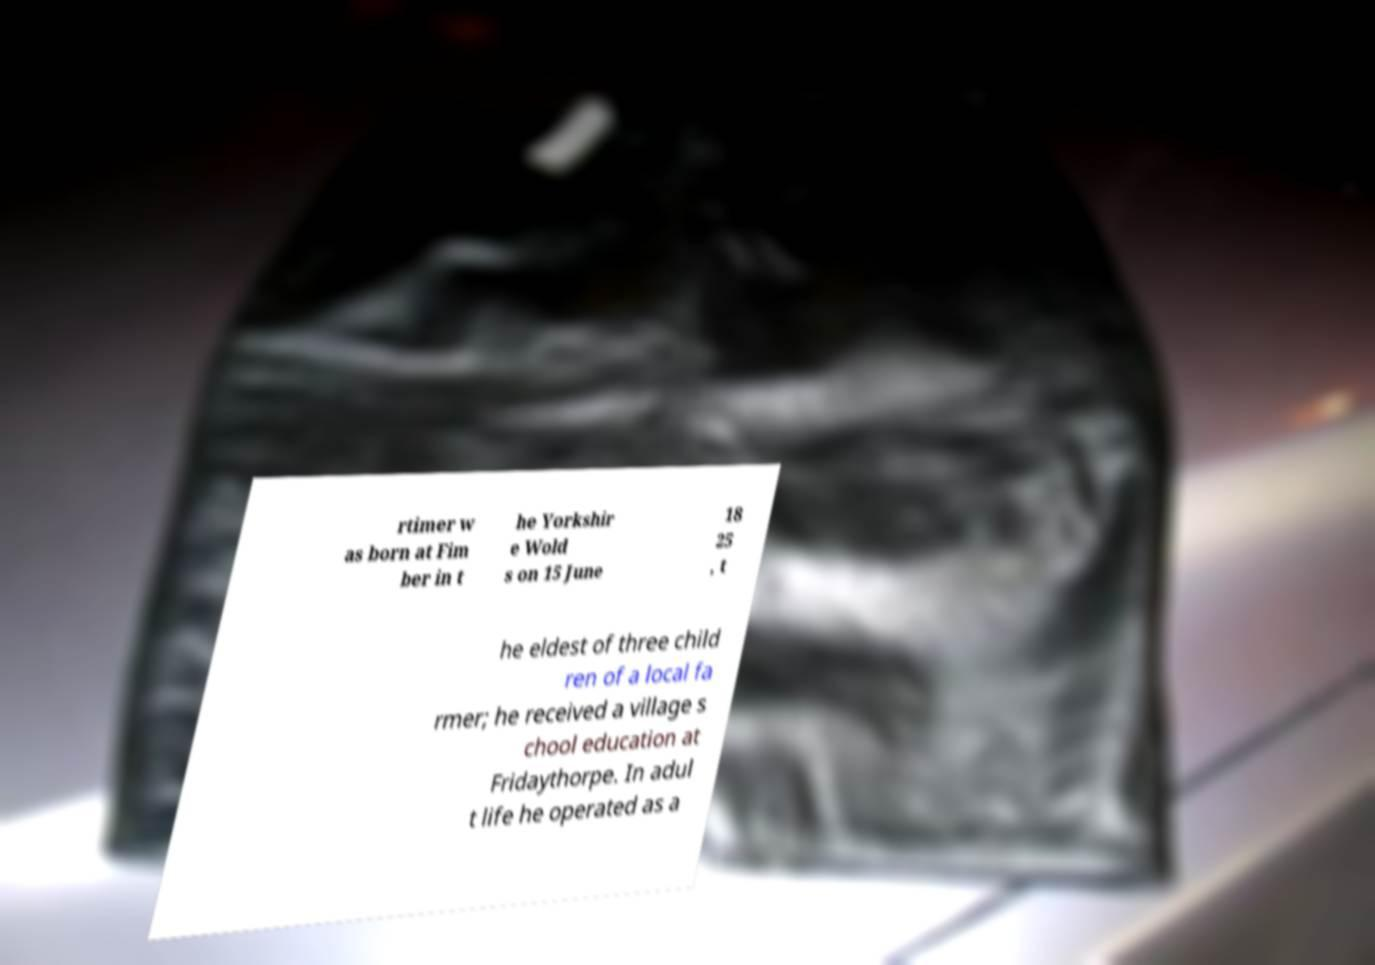Can you read and provide the text displayed in the image?This photo seems to have some interesting text. Can you extract and type it out for me? rtimer w as born at Fim ber in t he Yorkshir e Wold s on 15 June 18 25 , t he eldest of three child ren of a local fa rmer; he received a village s chool education at Fridaythorpe. In adul t life he operated as a 